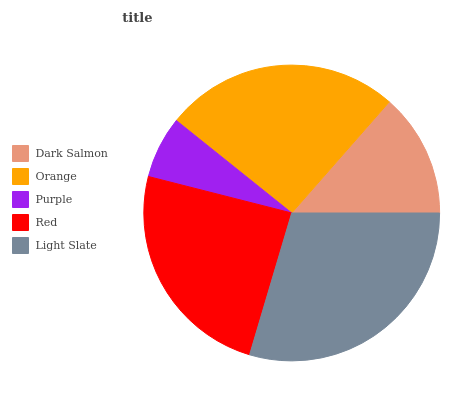Is Purple the minimum?
Answer yes or no. Yes. Is Light Slate the maximum?
Answer yes or no. Yes. Is Orange the minimum?
Answer yes or no. No. Is Orange the maximum?
Answer yes or no. No. Is Orange greater than Dark Salmon?
Answer yes or no. Yes. Is Dark Salmon less than Orange?
Answer yes or no. Yes. Is Dark Salmon greater than Orange?
Answer yes or no. No. Is Orange less than Dark Salmon?
Answer yes or no. No. Is Red the high median?
Answer yes or no. Yes. Is Red the low median?
Answer yes or no. Yes. Is Light Slate the high median?
Answer yes or no. No. Is Light Slate the low median?
Answer yes or no. No. 